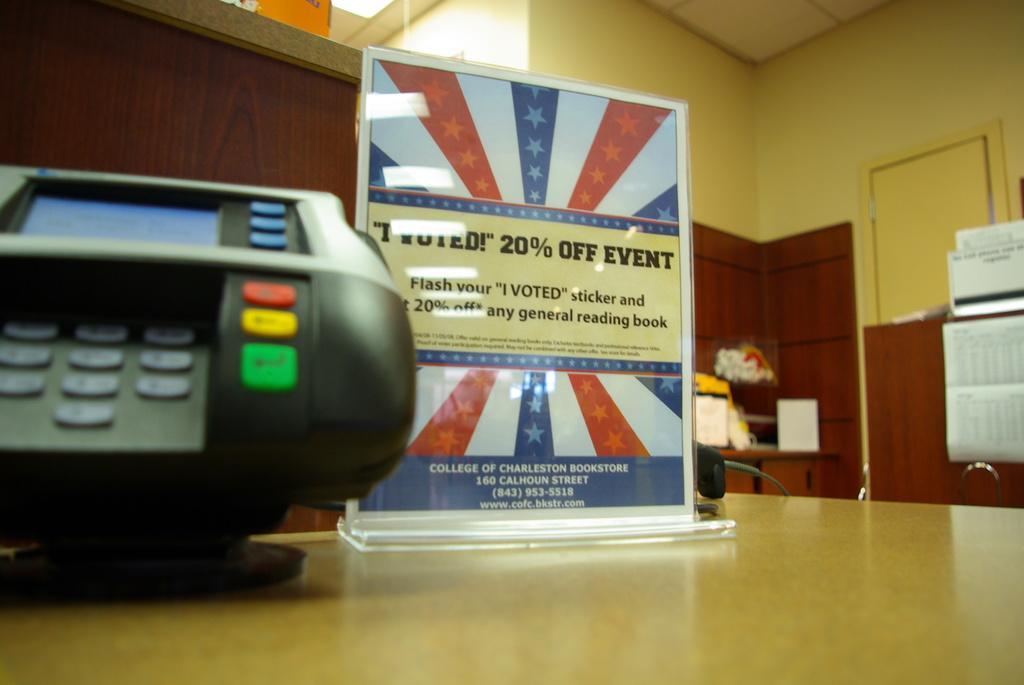Describe this image in one or two sentences. In this image there is an electronic device, a poster on the table, behind the table there is a flower bouquet and few notices. 